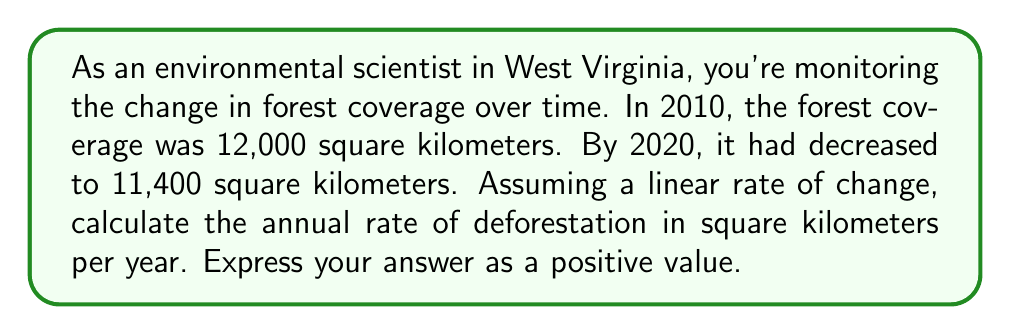Can you answer this question? To solve this problem, we'll use the linear equation for rate of change:

$$ \text{Rate of change} = \frac{\text{Change in y}}{\text{Change in x}} $$

1. Identify the known values:
   - Initial forest coverage (2010): 12,000 km²
   - Final forest coverage (2020): 11,400 km²
   - Time period: 10 years

2. Calculate the change in forest coverage:
   $$ \text{Change in forest coverage} = 11,400 - 12,000 = -600 \text{ km²} $$

3. Apply the rate of change formula:
   $$ \text{Rate of change} = \frac{-600 \text{ km²}}{10 \text{ years}} = -60 \text{ km²/year} $$

4. Express the rate as a positive value for deforestation:
   $$ \text{Deforestation rate} = 60 \text{ km²/year} $$

The negative sign in step 3 indicates a decrease in forest coverage. We remove this sign in the final answer to express the rate of deforestation as a positive value.
Answer: 60 km²/year 